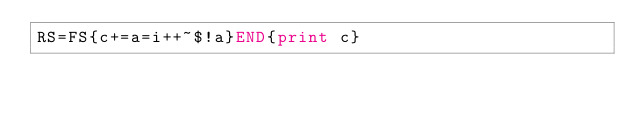Convert code to text. <code><loc_0><loc_0><loc_500><loc_500><_Awk_>RS=FS{c+=a=i++~$!a}END{print c}</code> 